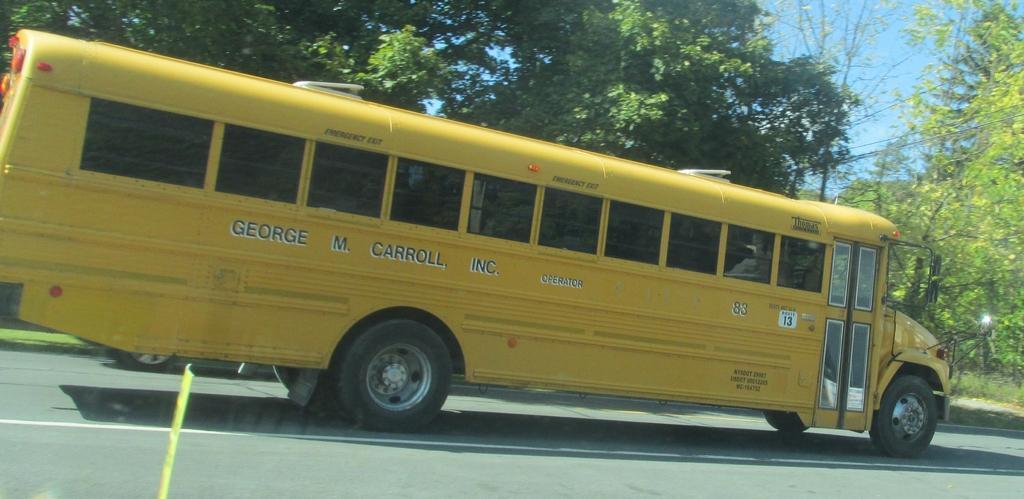How would you summarize this image in a sentence or two? In this image we can see a motor vehicle on the road, trees, electric cables and sky. 